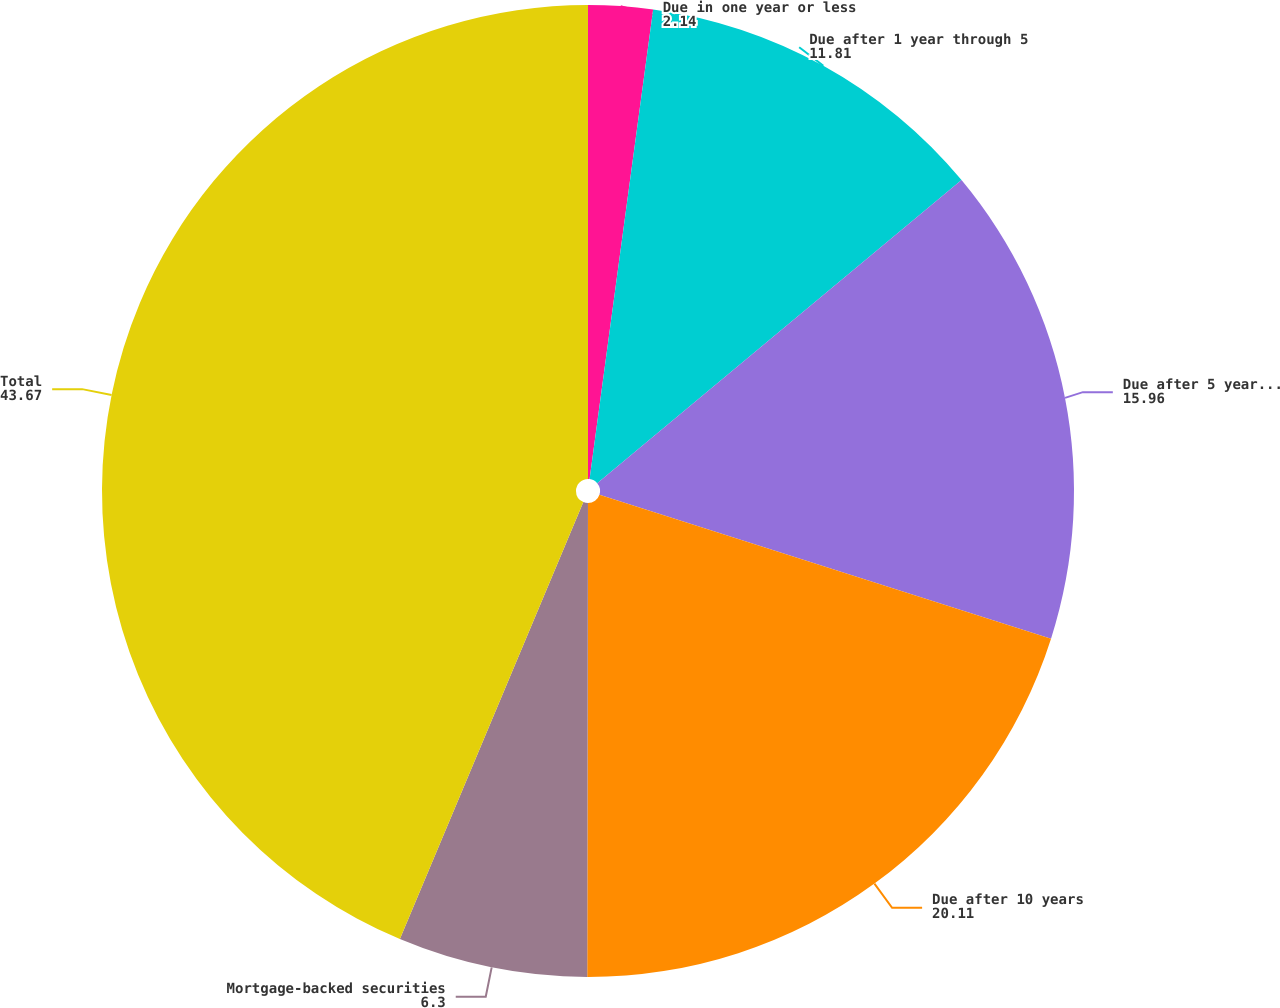Convert chart to OTSL. <chart><loc_0><loc_0><loc_500><loc_500><pie_chart><fcel>Due in one year or less<fcel>Due after 1 year through 5<fcel>Due after 5 years through 10<fcel>Due after 10 years<fcel>Mortgage-backed securities<fcel>Total<nl><fcel>2.14%<fcel>11.81%<fcel>15.96%<fcel>20.11%<fcel>6.3%<fcel>43.67%<nl></chart> 